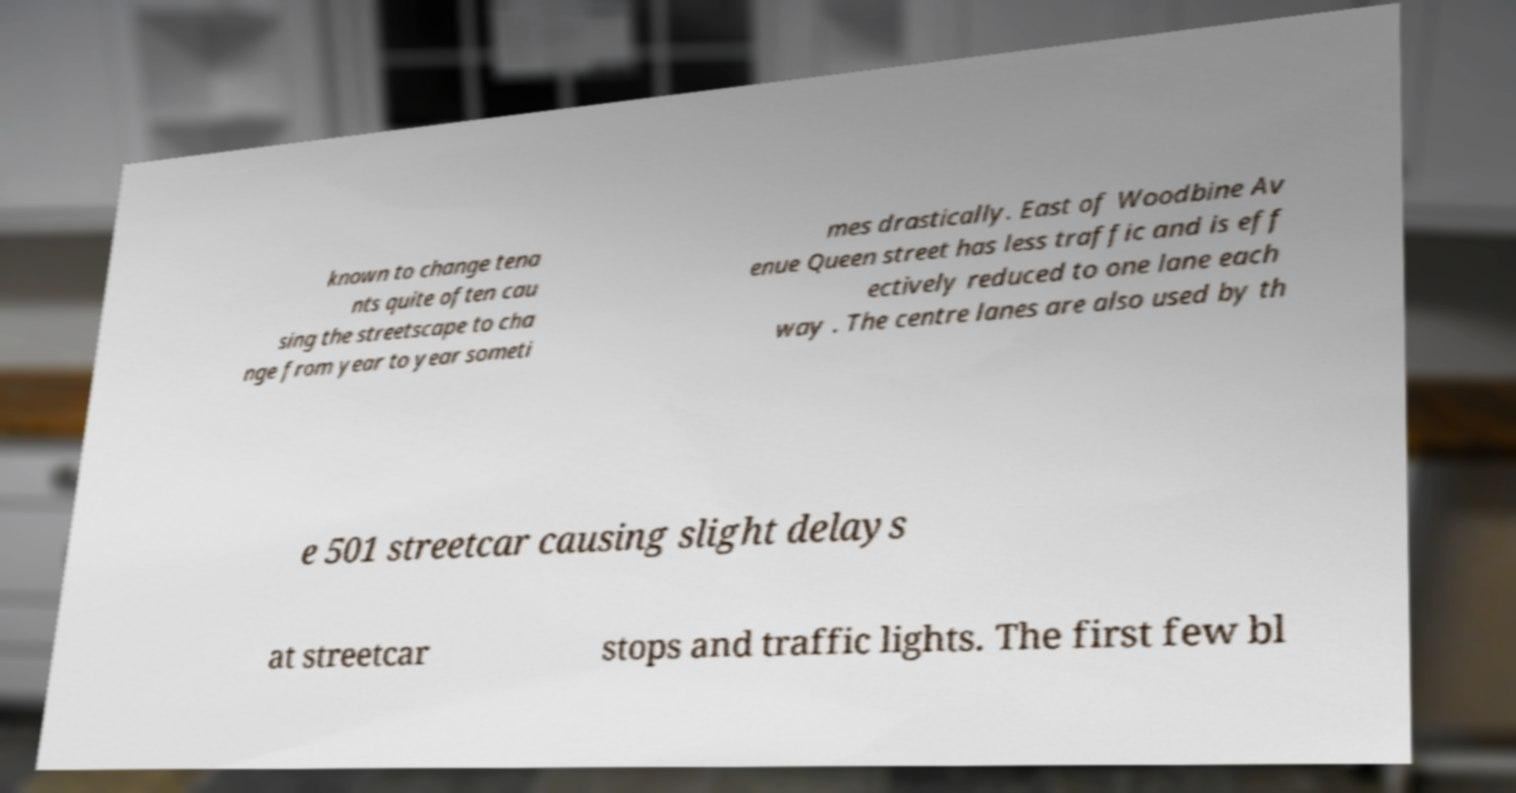Please read and relay the text visible in this image. What does it say? known to change tena nts quite often cau sing the streetscape to cha nge from year to year someti mes drastically. East of Woodbine Av enue Queen street has less traffic and is eff ectively reduced to one lane each way . The centre lanes are also used by th e 501 streetcar causing slight delays at streetcar stops and traffic lights. The first few bl 